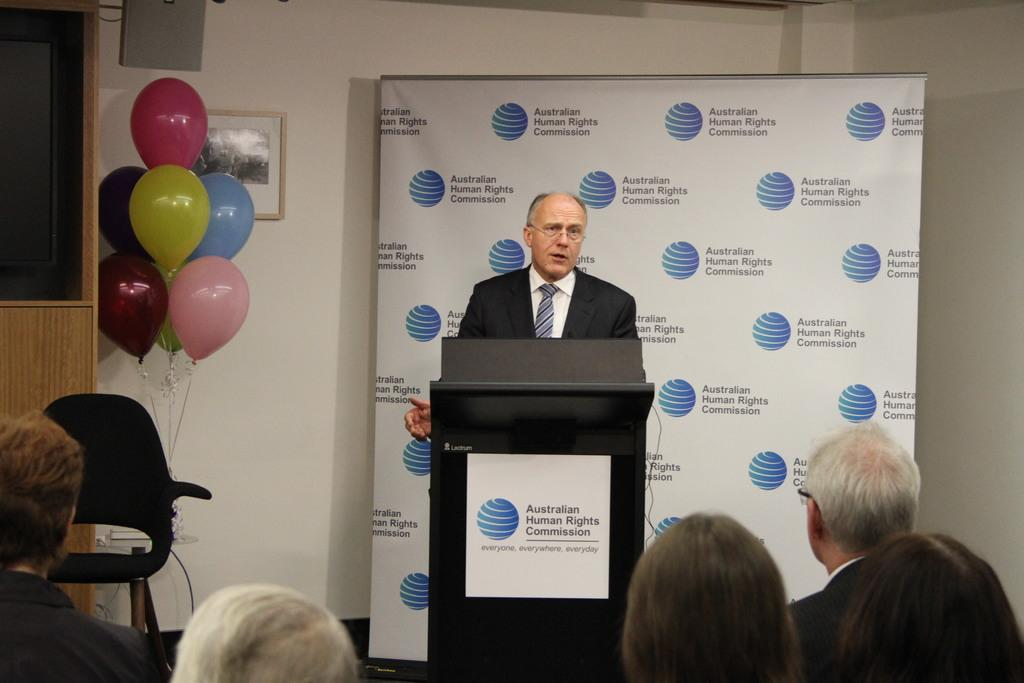<image>
Give a short and clear explanation of the subsequent image. A man standing at a podium that says Australian Human Rights Commission 